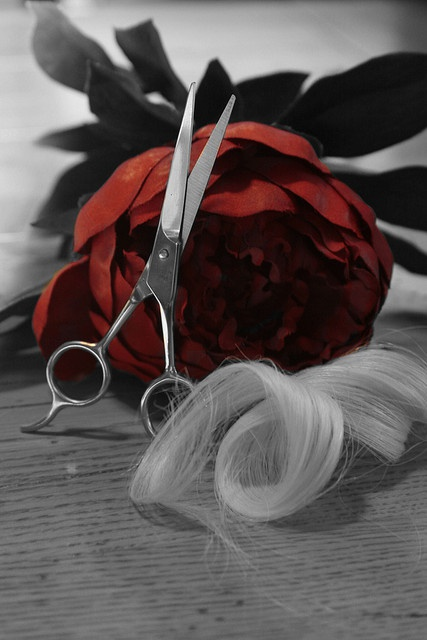Describe the objects in this image and their specific colors. I can see scissors in darkgray, black, gray, and lightgray tones in this image. 